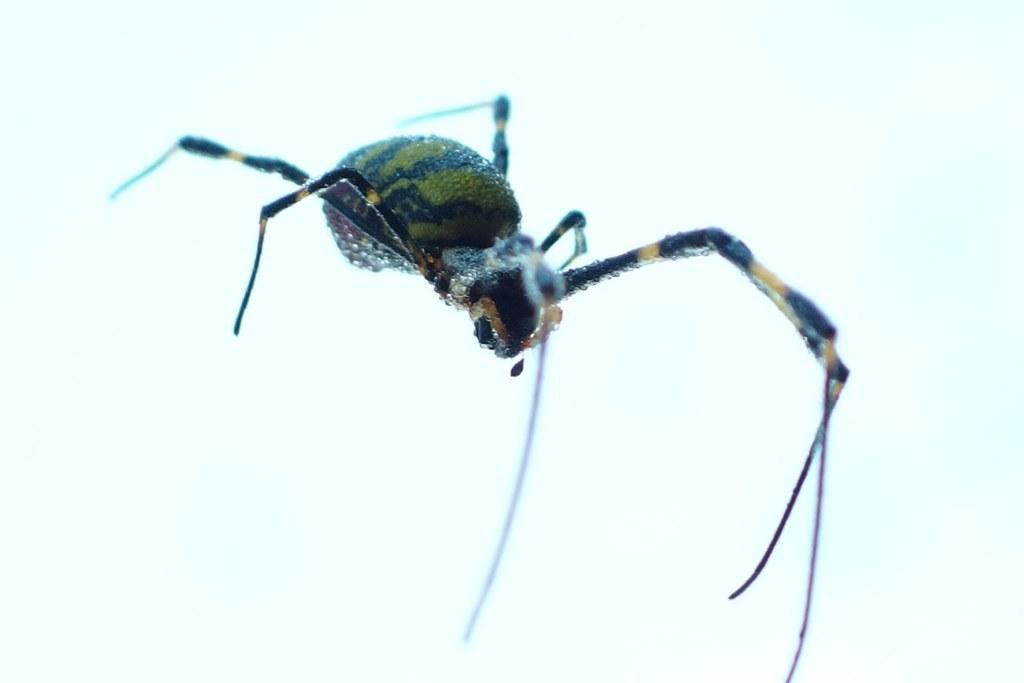Could you give a brief overview of what you see in this image? In this image I see a spider which is of green, black and yellow in color and it is white in the background. 